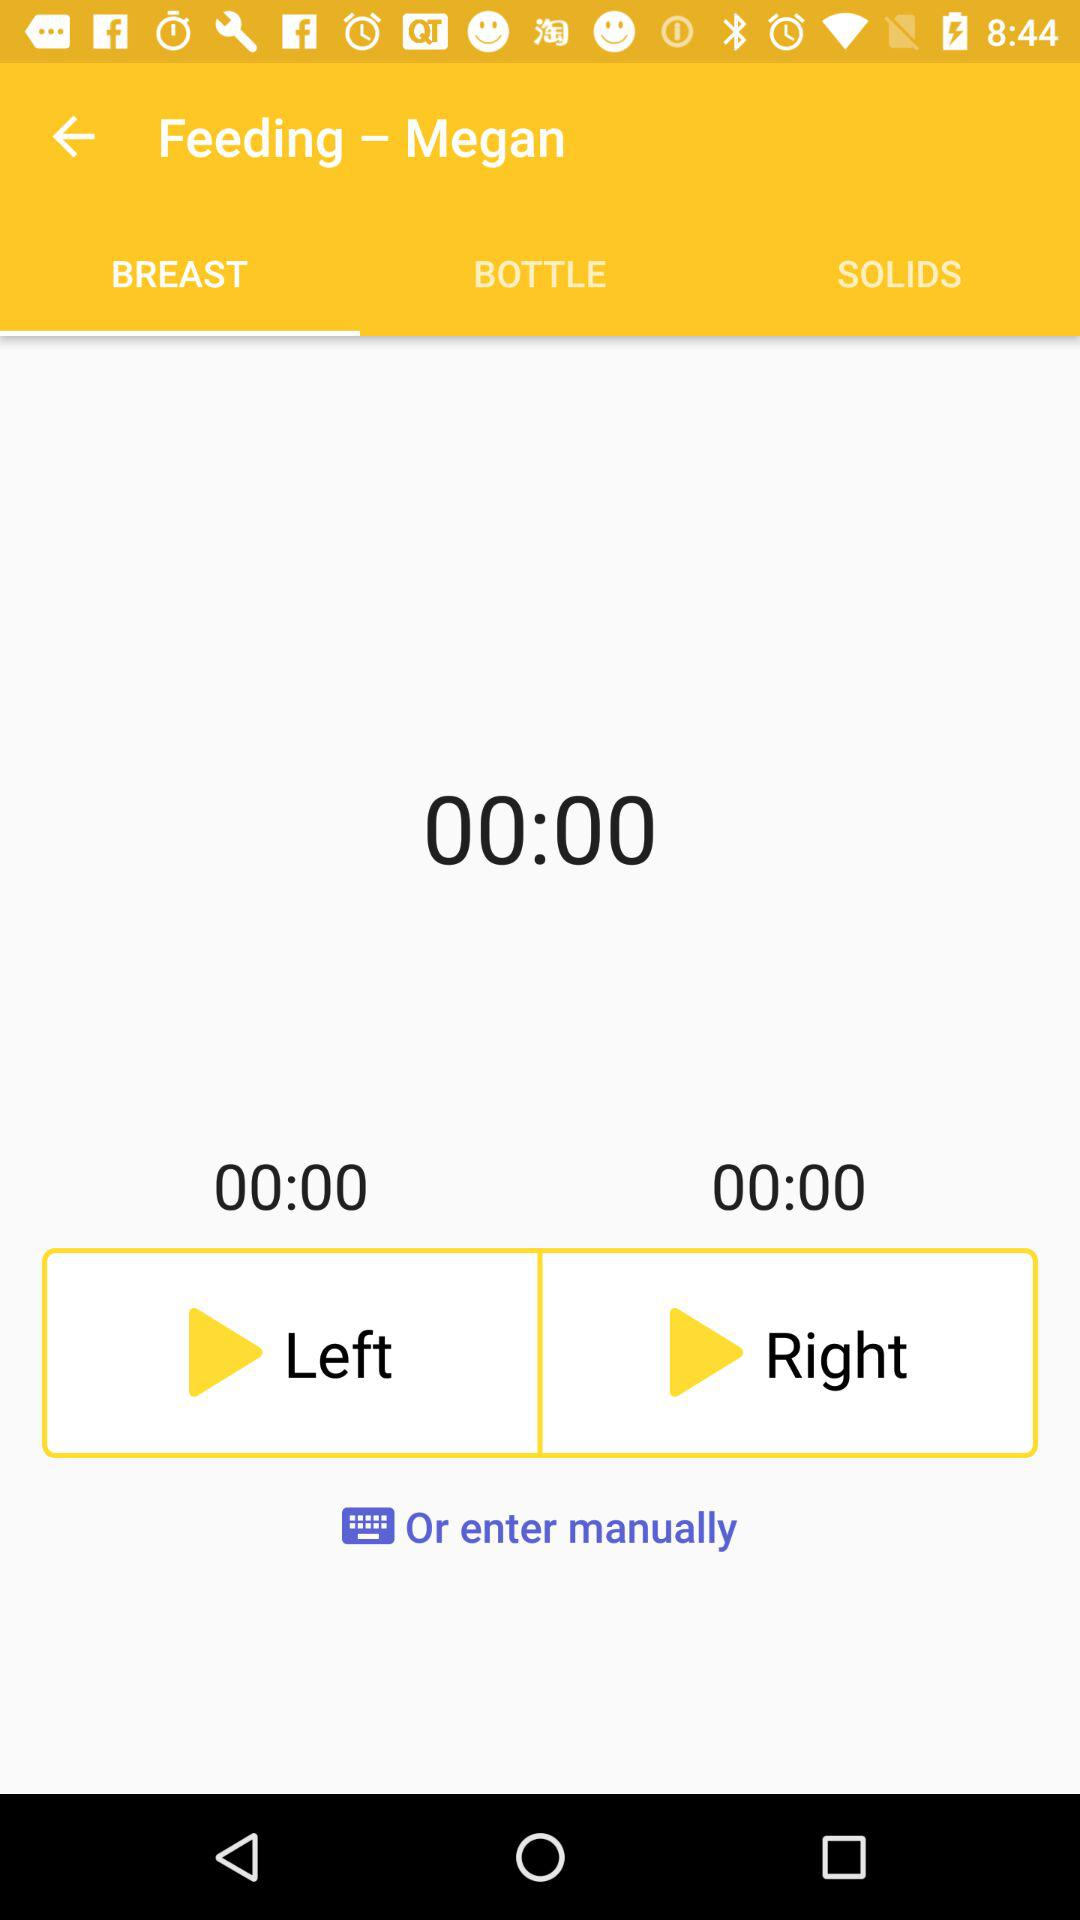How long has the left breast been feeding for?
Answer the question using a single word or phrase. 00:00 